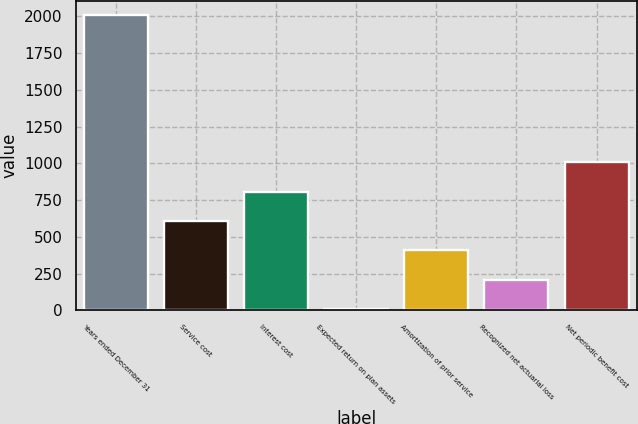Convert chart to OTSL. <chart><loc_0><loc_0><loc_500><loc_500><bar_chart><fcel>Years ended December 31<fcel>Service cost<fcel>Interest cost<fcel>Expected return on plan assets<fcel>Amortization of prior service<fcel>Recognized net actuarial loss<fcel>Net periodic benefit cost<nl><fcel>2008<fcel>608<fcel>808<fcel>8<fcel>408<fcel>208<fcel>1008<nl></chart> 